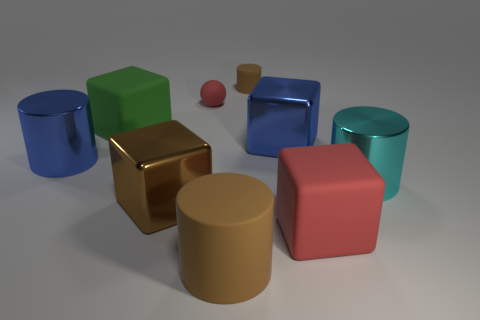Is the color of the large cylinder that is left of the large green matte object the same as the large metal block behind the brown metal cube? Yes, the large cylinder to the left of the green matte object and the large metal block behind the brown metal cube both share a similar hue of gold, exhibiting a shiny metallic finish that creates a reflective appearance. This common coloration between the two objects marks a visually coherent aspect within the image's composition. 